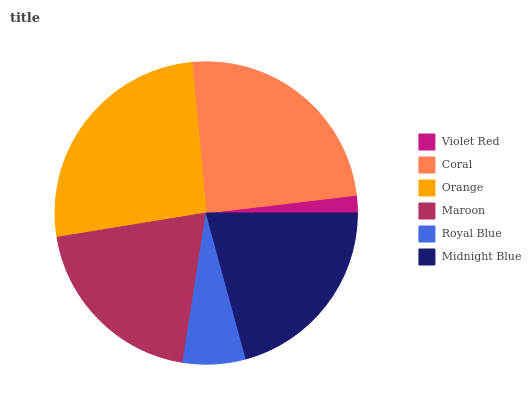Is Violet Red the minimum?
Answer yes or no. Yes. Is Orange the maximum?
Answer yes or no. Yes. Is Coral the minimum?
Answer yes or no. No. Is Coral the maximum?
Answer yes or no. No. Is Coral greater than Violet Red?
Answer yes or no. Yes. Is Violet Red less than Coral?
Answer yes or no. Yes. Is Violet Red greater than Coral?
Answer yes or no. No. Is Coral less than Violet Red?
Answer yes or no. No. Is Midnight Blue the high median?
Answer yes or no. Yes. Is Maroon the low median?
Answer yes or no. Yes. Is Orange the high median?
Answer yes or no. No. Is Coral the low median?
Answer yes or no. No. 